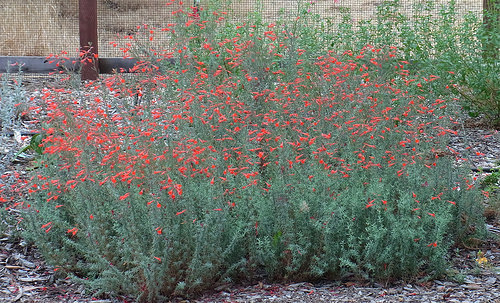<image>
Can you confirm if the flower is above the plant? No. The flower is not positioned above the plant. The vertical arrangement shows a different relationship. 